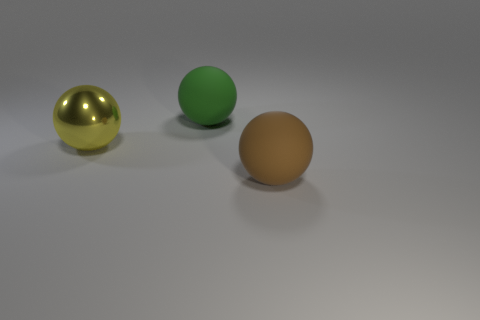Are there fewer big rubber balls on the left side of the large metal thing than large green rubber spheres that are in front of the big brown matte thing?
Offer a very short reply. No. Is there any other thing that is the same shape as the big yellow object?
Give a very brief answer. Yes. There is a large rubber thing right of the big rubber thing that is to the left of the big brown matte sphere; how many metallic balls are to the left of it?
Provide a succinct answer. 1. How many big green rubber spheres are behind the metal sphere?
Your answer should be very brief. 1. How many green balls have the same material as the green thing?
Ensure brevity in your answer.  0. There is a big ball that is made of the same material as the big brown object; what is its color?
Keep it short and to the point. Green. The big sphere on the left side of the big matte thing that is behind the brown ball in front of the yellow ball is made of what material?
Your response must be concise. Metal. Do the rubber thing that is in front of the metallic ball and the big green matte thing have the same size?
Your answer should be compact. Yes. What number of tiny things are brown rubber balls or yellow rubber balls?
Your response must be concise. 0. How many objects are either large spheres behind the brown rubber ball or tiny red metal cylinders?
Give a very brief answer. 2. 